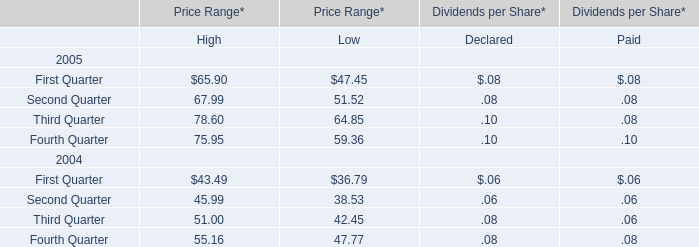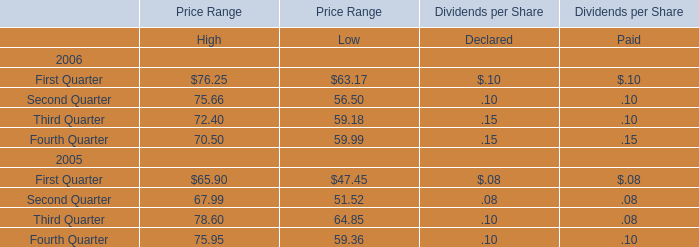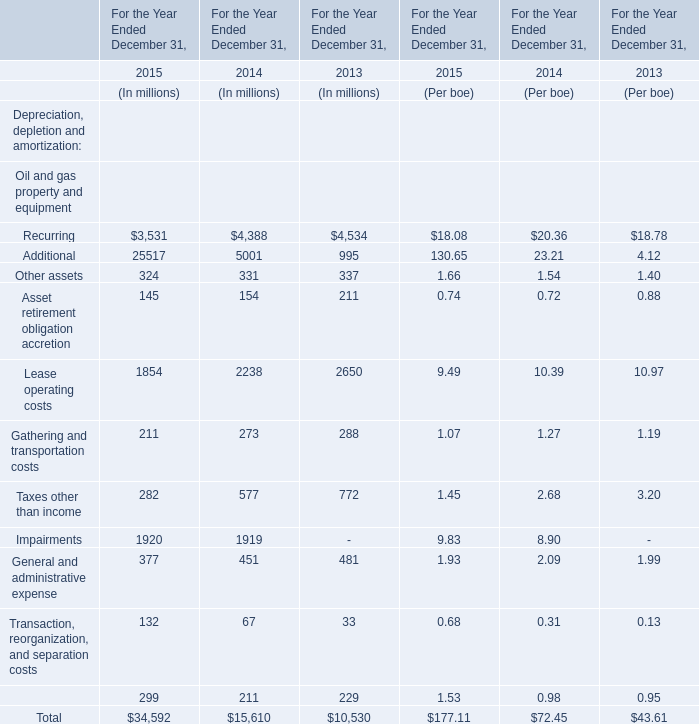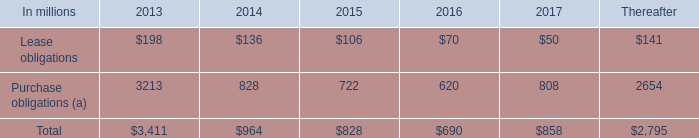What's the average of Recurring in 2015, 2014, and 2013? (in millions) 
Computations: (((3531 + 4388) + 4534) / 3)
Answer: 4151.0. 